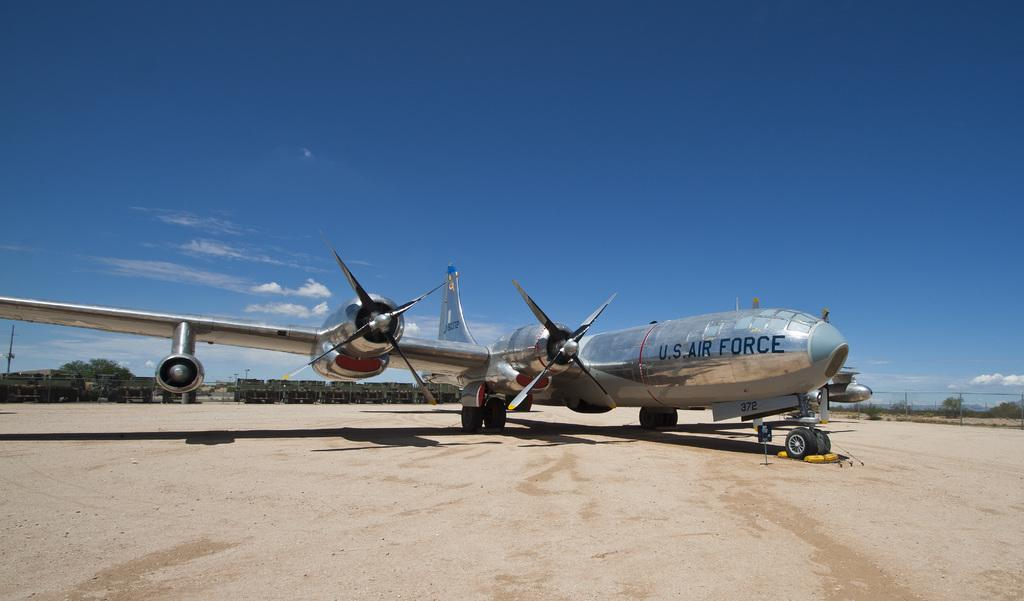<image>
Present a compact description of the photo's key features. The silver airplane is part of the US Air Force. 